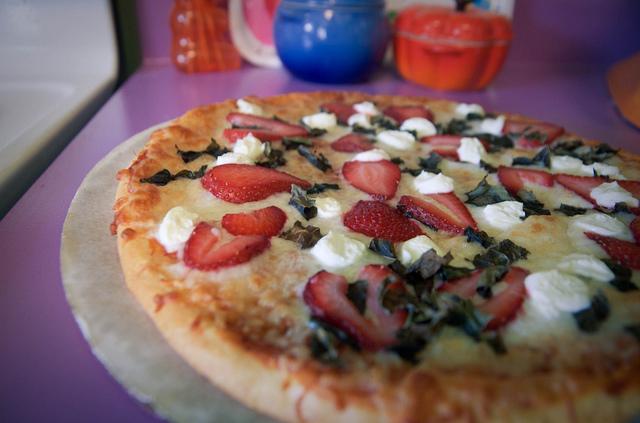What food is this?
Concise answer only. Pizza. Where is the pizza?
Short answer required. Table. How many strawberries are on the pie?
Answer briefly. 16. What is the color of the cloth were the plate is?
Give a very brief answer. Purple. 